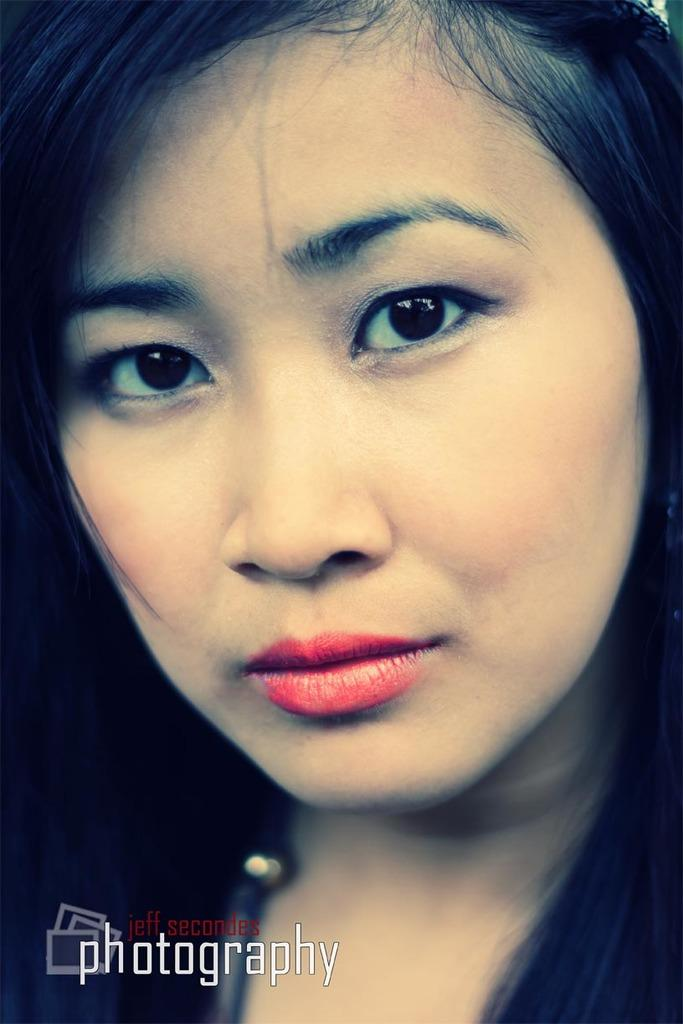Who is present in the image? There is a woman in the image. What can be found at the bottom of the image? There is text at the bottom of the image. How many tomatoes are on the furniture in the image? There are no tomatoes or furniture present in the image. 